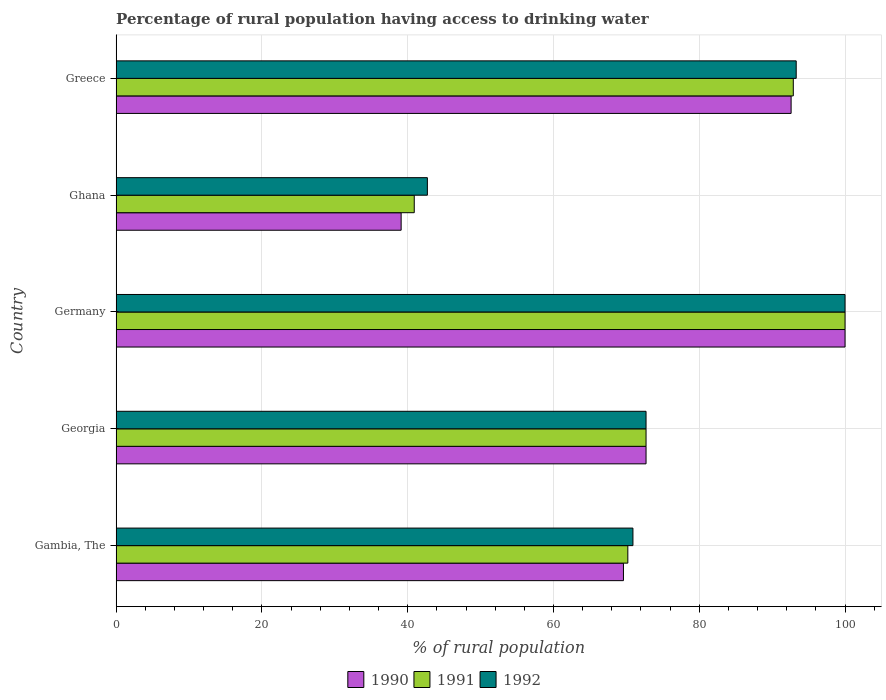How many different coloured bars are there?
Your response must be concise. 3. How many groups of bars are there?
Make the answer very short. 5. Are the number of bars on each tick of the Y-axis equal?
Keep it short and to the point. Yes. How many bars are there on the 4th tick from the top?
Your response must be concise. 3. How many bars are there on the 3rd tick from the bottom?
Provide a short and direct response. 3. What is the label of the 5th group of bars from the top?
Your response must be concise. Gambia, The. What is the percentage of rural population having access to drinking water in 1990 in Greece?
Your answer should be very brief. 92.6. Across all countries, what is the maximum percentage of rural population having access to drinking water in 1990?
Your answer should be compact. 100. Across all countries, what is the minimum percentage of rural population having access to drinking water in 1990?
Offer a terse response. 39.1. In which country was the percentage of rural population having access to drinking water in 1991 maximum?
Provide a succinct answer. Germany. What is the total percentage of rural population having access to drinking water in 1991 in the graph?
Give a very brief answer. 376.7. What is the difference between the percentage of rural population having access to drinking water in 1990 in Germany and that in Greece?
Provide a succinct answer. 7.4. What is the difference between the percentage of rural population having access to drinking water in 1990 in Gambia, The and the percentage of rural population having access to drinking water in 1992 in Greece?
Offer a very short reply. -23.7. What is the average percentage of rural population having access to drinking water in 1991 per country?
Offer a terse response. 75.34. In how many countries, is the percentage of rural population having access to drinking water in 1991 greater than 28 %?
Provide a short and direct response. 5. What is the ratio of the percentage of rural population having access to drinking water in 1992 in Gambia, The to that in Georgia?
Your answer should be compact. 0.98. Is the difference between the percentage of rural population having access to drinking water in 1991 in Gambia, The and Greece greater than the difference between the percentage of rural population having access to drinking water in 1992 in Gambia, The and Greece?
Provide a short and direct response. No. What is the difference between the highest and the second highest percentage of rural population having access to drinking water in 1990?
Give a very brief answer. 7.4. What is the difference between the highest and the lowest percentage of rural population having access to drinking water in 1991?
Provide a short and direct response. 59.1. In how many countries, is the percentage of rural population having access to drinking water in 1992 greater than the average percentage of rural population having access to drinking water in 1992 taken over all countries?
Give a very brief answer. 2. Is the sum of the percentage of rural population having access to drinking water in 1990 in Germany and Greece greater than the maximum percentage of rural population having access to drinking water in 1992 across all countries?
Ensure brevity in your answer.  Yes. What does the 2nd bar from the top in Greece represents?
Your answer should be compact. 1991. How many bars are there?
Ensure brevity in your answer.  15. Are all the bars in the graph horizontal?
Your answer should be compact. Yes. How many countries are there in the graph?
Keep it short and to the point. 5. Does the graph contain any zero values?
Provide a succinct answer. No. Where does the legend appear in the graph?
Offer a terse response. Bottom center. What is the title of the graph?
Offer a terse response. Percentage of rural population having access to drinking water. What is the label or title of the X-axis?
Make the answer very short. % of rural population. What is the % of rural population in 1990 in Gambia, The?
Provide a succinct answer. 69.6. What is the % of rural population in 1991 in Gambia, The?
Your answer should be compact. 70.2. What is the % of rural population of 1992 in Gambia, The?
Your answer should be very brief. 70.9. What is the % of rural population of 1990 in Georgia?
Make the answer very short. 72.7. What is the % of rural population of 1991 in Georgia?
Offer a terse response. 72.7. What is the % of rural population of 1992 in Georgia?
Provide a succinct answer. 72.7. What is the % of rural population in 1991 in Germany?
Your response must be concise. 100. What is the % of rural population of 1992 in Germany?
Ensure brevity in your answer.  100. What is the % of rural population in 1990 in Ghana?
Keep it short and to the point. 39.1. What is the % of rural population in 1991 in Ghana?
Offer a very short reply. 40.9. What is the % of rural population of 1992 in Ghana?
Ensure brevity in your answer.  42.7. What is the % of rural population of 1990 in Greece?
Provide a succinct answer. 92.6. What is the % of rural population in 1991 in Greece?
Your answer should be compact. 92.9. What is the % of rural population in 1992 in Greece?
Offer a terse response. 93.3. Across all countries, what is the maximum % of rural population of 1990?
Your answer should be very brief. 100. Across all countries, what is the minimum % of rural population in 1990?
Give a very brief answer. 39.1. Across all countries, what is the minimum % of rural population of 1991?
Offer a terse response. 40.9. Across all countries, what is the minimum % of rural population in 1992?
Your answer should be compact. 42.7. What is the total % of rural population in 1990 in the graph?
Your answer should be compact. 374. What is the total % of rural population in 1991 in the graph?
Offer a very short reply. 376.7. What is the total % of rural population of 1992 in the graph?
Offer a terse response. 379.6. What is the difference between the % of rural population in 1990 in Gambia, The and that in Germany?
Make the answer very short. -30.4. What is the difference between the % of rural population in 1991 in Gambia, The and that in Germany?
Give a very brief answer. -29.8. What is the difference between the % of rural population in 1992 in Gambia, The and that in Germany?
Your answer should be very brief. -29.1. What is the difference between the % of rural population in 1990 in Gambia, The and that in Ghana?
Offer a terse response. 30.5. What is the difference between the % of rural population in 1991 in Gambia, The and that in Ghana?
Your answer should be compact. 29.3. What is the difference between the % of rural population in 1992 in Gambia, The and that in Ghana?
Your answer should be compact. 28.2. What is the difference between the % of rural population of 1990 in Gambia, The and that in Greece?
Give a very brief answer. -23. What is the difference between the % of rural population of 1991 in Gambia, The and that in Greece?
Your answer should be very brief. -22.7. What is the difference between the % of rural population of 1992 in Gambia, The and that in Greece?
Ensure brevity in your answer.  -22.4. What is the difference between the % of rural population in 1990 in Georgia and that in Germany?
Provide a short and direct response. -27.3. What is the difference between the % of rural population of 1991 in Georgia and that in Germany?
Ensure brevity in your answer.  -27.3. What is the difference between the % of rural population in 1992 in Georgia and that in Germany?
Provide a short and direct response. -27.3. What is the difference between the % of rural population of 1990 in Georgia and that in Ghana?
Give a very brief answer. 33.6. What is the difference between the % of rural population in 1991 in Georgia and that in Ghana?
Offer a terse response. 31.8. What is the difference between the % of rural population in 1990 in Georgia and that in Greece?
Keep it short and to the point. -19.9. What is the difference between the % of rural population in 1991 in Georgia and that in Greece?
Ensure brevity in your answer.  -20.2. What is the difference between the % of rural population of 1992 in Georgia and that in Greece?
Keep it short and to the point. -20.6. What is the difference between the % of rural population of 1990 in Germany and that in Ghana?
Your answer should be very brief. 60.9. What is the difference between the % of rural population of 1991 in Germany and that in Ghana?
Provide a short and direct response. 59.1. What is the difference between the % of rural population in 1992 in Germany and that in Ghana?
Make the answer very short. 57.3. What is the difference between the % of rural population in 1990 in Germany and that in Greece?
Your response must be concise. 7.4. What is the difference between the % of rural population in 1991 in Germany and that in Greece?
Keep it short and to the point. 7.1. What is the difference between the % of rural population in 1992 in Germany and that in Greece?
Keep it short and to the point. 6.7. What is the difference between the % of rural population in 1990 in Ghana and that in Greece?
Offer a very short reply. -53.5. What is the difference between the % of rural population of 1991 in Ghana and that in Greece?
Your answer should be very brief. -52. What is the difference between the % of rural population in 1992 in Ghana and that in Greece?
Keep it short and to the point. -50.6. What is the difference between the % of rural population of 1990 in Gambia, The and the % of rural population of 1991 in Georgia?
Keep it short and to the point. -3.1. What is the difference between the % of rural population of 1990 in Gambia, The and the % of rural population of 1991 in Germany?
Offer a terse response. -30.4. What is the difference between the % of rural population in 1990 in Gambia, The and the % of rural population in 1992 in Germany?
Provide a short and direct response. -30.4. What is the difference between the % of rural population of 1991 in Gambia, The and the % of rural population of 1992 in Germany?
Provide a short and direct response. -29.8. What is the difference between the % of rural population of 1990 in Gambia, The and the % of rural population of 1991 in Ghana?
Ensure brevity in your answer.  28.7. What is the difference between the % of rural population in 1990 in Gambia, The and the % of rural population in 1992 in Ghana?
Your answer should be very brief. 26.9. What is the difference between the % of rural population of 1991 in Gambia, The and the % of rural population of 1992 in Ghana?
Provide a succinct answer. 27.5. What is the difference between the % of rural population of 1990 in Gambia, The and the % of rural population of 1991 in Greece?
Provide a succinct answer. -23.3. What is the difference between the % of rural population in 1990 in Gambia, The and the % of rural population in 1992 in Greece?
Ensure brevity in your answer.  -23.7. What is the difference between the % of rural population of 1991 in Gambia, The and the % of rural population of 1992 in Greece?
Your response must be concise. -23.1. What is the difference between the % of rural population of 1990 in Georgia and the % of rural population of 1991 in Germany?
Offer a terse response. -27.3. What is the difference between the % of rural population of 1990 in Georgia and the % of rural population of 1992 in Germany?
Your answer should be very brief. -27.3. What is the difference between the % of rural population of 1991 in Georgia and the % of rural population of 1992 in Germany?
Ensure brevity in your answer.  -27.3. What is the difference between the % of rural population in 1990 in Georgia and the % of rural population in 1991 in Ghana?
Offer a terse response. 31.8. What is the difference between the % of rural population of 1990 in Georgia and the % of rural population of 1992 in Ghana?
Keep it short and to the point. 30. What is the difference between the % of rural population of 1990 in Georgia and the % of rural population of 1991 in Greece?
Provide a short and direct response. -20.2. What is the difference between the % of rural population in 1990 in Georgia and the % of rural population in 1992 in Greece?
Offer a terse response. -20.6. What is the difference between the % of rural population in 1991 in Georgia and the % of rural population in 1992 in Greece?
Your answer should be compact. -20.6. What is the difference between the % of rural population of 1990 in Germany and the % of rural population of 1991 in Ghana?
Give a very brief answer. 59.1. What is the difference between the % of rural population in 1990 in Germany and the % of rural population in 1992 in Ghana?
Ensure brevity in your answer.  57.3. What is the difference between the % of rural population in 1991 in Germany and the % of rural population in 1992 in Ghana?
Give a very brief answer. 57.3. What is the difference between the % of rural population of 1990 in Ghana and the % of rural population of 1991 in Greece?
Offer a very short reply. -53.8. What is the difference between the % of rural population in 1990 in Ghana and the % of rural population in 1992 in Greece?
Provide a short and direct response. -54.2. What is the difference between the % of rural population of 1991 in Ghana and the % of rural population of 1992 in Greece?
Provide a succinct answer. -52.4. What is the average % of rural population of 1990 per country?
Keep it short and to the point. 74.8. What is the average % of rural population of 1991 per country?
Keep it short and to the point. 75.34. What is the average % of rural population of 1992 per country?
Make the answer very short. 75.92. What is the difference between the % of rural population of 1991 and % of rural population of 1992 in Gambia, The?
Give a very brief answer. -0.7. What is the difference between the % of rural population in 1990 and % of rural population in 1991 in Georgia?
Your response must be concise. 0. What is the difference between the % of rural population of 1990 and % of rural population of 1991 in Germany?
Make the answer very short. 0. What is the difference between the % of rural population in 1991 and % of rural population in 1992 in Germany?
Ensure brevity in your answer.  0. What is the difference between the % of rural population in 1990 and % of rural population in 1992 in Ghana?
Give a very brief answer. -3.6. What is the difference between the % of rural population in 1991 and % of rural population in 1992 in Ghana?
Ensure brevity in your answer.  -1.8. What is the difference between the % of rural population in 1990 and % of rural population in 1991 in Greece?
Keep it short and to the point. -0.3. What is the difference between the % of rural population in 1991 and % of rural population in 1992 in Greece?
Keep it short and to the point. -0.4. What is the ratio of the % of rural population of 1990 in Gambia, The to that in Georgia?
Offer a terse response. 0.96. What is the ratio of the % of rural population in 1991 in Gambia, The to that in Georgia?
Keep it short and to the point. 0.97. What is the ratio of the % of rural population of 1992 in Gambia, The to that in Georgia?
Provide a short and direct response. 0.98. What is the ratio of the % of rural population in 1990 in Gambia, The to that in Germany?
Your response must be concise. 0.7. What is the ratio of the % of rural population in 1991 in Gambia, The to that in Germany?
Provide a succinct answer. 0.7. What is the ratio of the % of rural population in 1992 in Gambia, The to that in Germany?
Provide a short and direct response. 0.71. What is the ratio of the % of rural population in 1990 in Gambia, The to that in Ghana?
Your answer should be very brief. 1.78. What is the ratio of the % of rural population of 1991 in Gambia, The to that in Ghana?
Ensure brevity in your answer.  1.72. What is the ratio of the % of rural population in 1992 in Gambia, The to that in Ghana?
Offer a terse response. 1.66. What is the ratio of the % of rural population of 1990 in Gambia, The to that in Greece?
Ensure brevity in your answer.  0.75. What is the ratio of the % of rural population in 1991 in Gambia, The to that in Greece?
Your response must be concise. 0.76. What is the ratio of the % of rural population of 1992 in Gambia, The to that in Greece?
Your answer should be compact. 0.76. What is the ratio of the % of rural population in 1990 in Georgia to that in Germany?
Keep it short and to the point. 0.73. What is the ratio of the % of rural population of 1991 in Georgia to that in Germany?
Make the answer very short. 0.73. What is the ratio of the % of rural population of 1992 in Georgia to that in Germany?
Provide a short and direct response. 0.73. What is the ratio of the % of rural population in 1990 in Georgia to that in Ghana?
Make the answer very short. 1.86. What is the ratio of the % of rural population in 1991 in Georgia to that in Ghana?
Provide a short and direct response. 1.78. What is the ratio of the % of rural population in 1992 in Georgia to that in Ghana?
Offer a terse response. 1.7. What is the ratio of the % of rural population in 1990 in Georgia to that in Greece?
Your answer should be compact. 0.79. What is the ratio of the % of rural population of 1991 in Georgia to that in Greece?
Keep it short and to the point. 0.78. What is the ratio of the % of rural population of 1992 in Georgia to that in Greece?
Your answer should be very brief. 0.78. What is the ratio of the % of rural population in 1990 in Germany to that in Ghana?
Ensure brevity in your answer.  2.56. What is the ratio of the % of rural population of 1991 in Germany to that in Ghana?
Keep it short and to the point. 2.44. What is the ratio of the % of rural population of 1992 in Germany to that in Ghana?
Make the answer very short. 2.34. What is the ratio of the % of rural population of 1990 in Germany to that in Greece?
Offer a terse response. 1.08. What is the ratio of the % of rural population of 1991 in Germany to that in Greece?
Provide a succinct answer. 1.08. What is the ratio of the % of rural population in 1992 in Germany to that in Greece?
Offer a terse response. 1.07. What is the ratio of the % of rural population of 1990 in Ghana to that in Greece?
Your answer should be compact. 0.42. What is the ratio of the % of rural population of 1991 in Ghana to that in Greece?
Your response must be concise. 0.44. What is the ratio of the % of rural population of 1992 in Ghana to that in Greece?
Make the answer very short. 0.46. What is the difference between the highest and the second highest % of rural population in 1991?
Your answer should be compact. 7.1. What is the difference between the highest and the lowest % of rural population in 1990?
Make the answer very short. 60.9. What is the difference between the highest and the lowest % of rural population in 1991?
Provide a short and direct response. 59.1. What is the difference between the highest and the lowest % of rural population of 1992?
Provide a short and direct response. 57.3. 